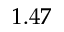<formula> <loc_0><loc_0><loc_500><loc_500>1 . 4 7</formula> 